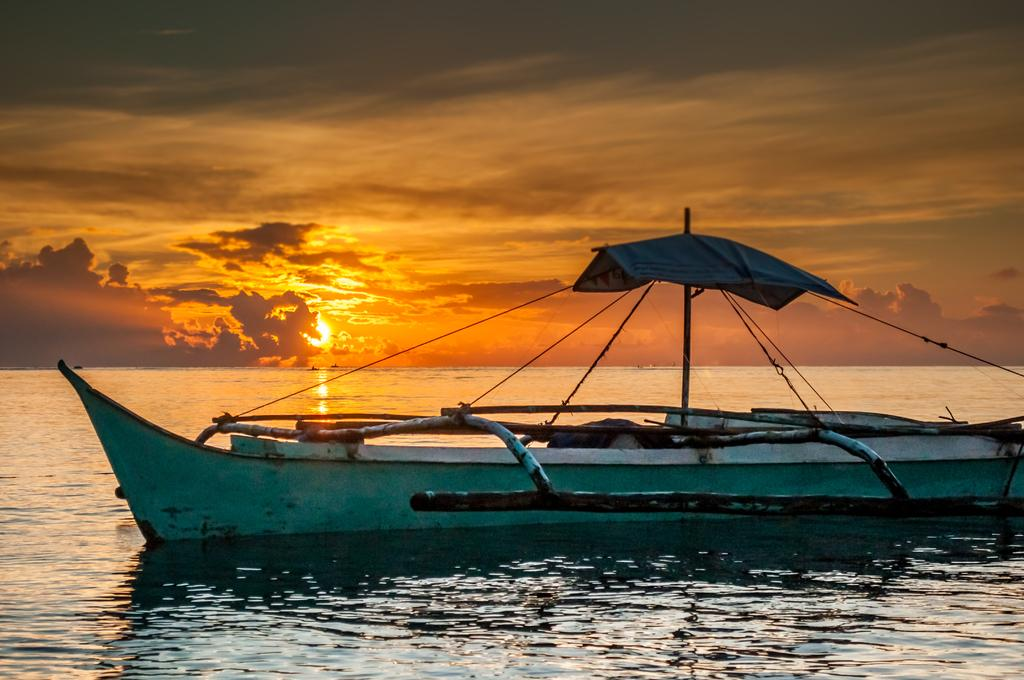What is the main subject of the image? The main subject of the image is a boat. Where is the boat located? The boat is in the water. What can be seen in the sky in the image? The sun is visible in the image, and there are clouds present in the sky. What type of cord is being used to control the boat in the image? There is no cord visible in the image, and the boat is not being controlled by any visible means. 